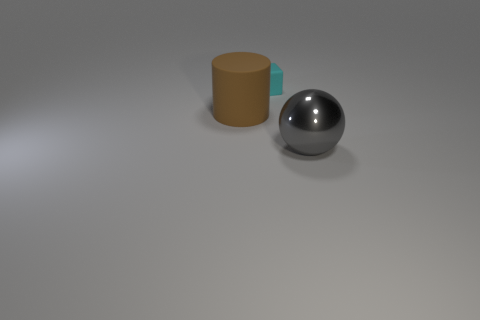What number of matte objects are either large brown objects or cyan blocks?
Offer a terse response. 2. Is the small thing the same color as the large cylinder?
Provide a succinct answer. No. Is the number of tiny rubber things that are in front of the shiny object greater than the number of cyan matte things?
Offer a very short reply. No. How many other things are there of the same material as the gray object?
Your answer should be compact. 0. How many small objects are cyan shiny objects or cyan objects?
Your answer should be very brief. 1. Does the big gray sphere have the same material as the large cylinder?
Provide a short and direct response. No. There is a object to the right of the tiny cube; how many things are behind it?
Provide a short and direct response. 2. Are there the same number of blue rubber blocks and brown rubber cylinders?
Offer a very short reply. No. Are there any other matte objects of the same shape as the large gray object?
Provide a succinct answer. No. Does the large object behind the big gray sphere have the same shape as the matte thing to the right of the big brown rubber thing?
Keep it short and to the point. No. 